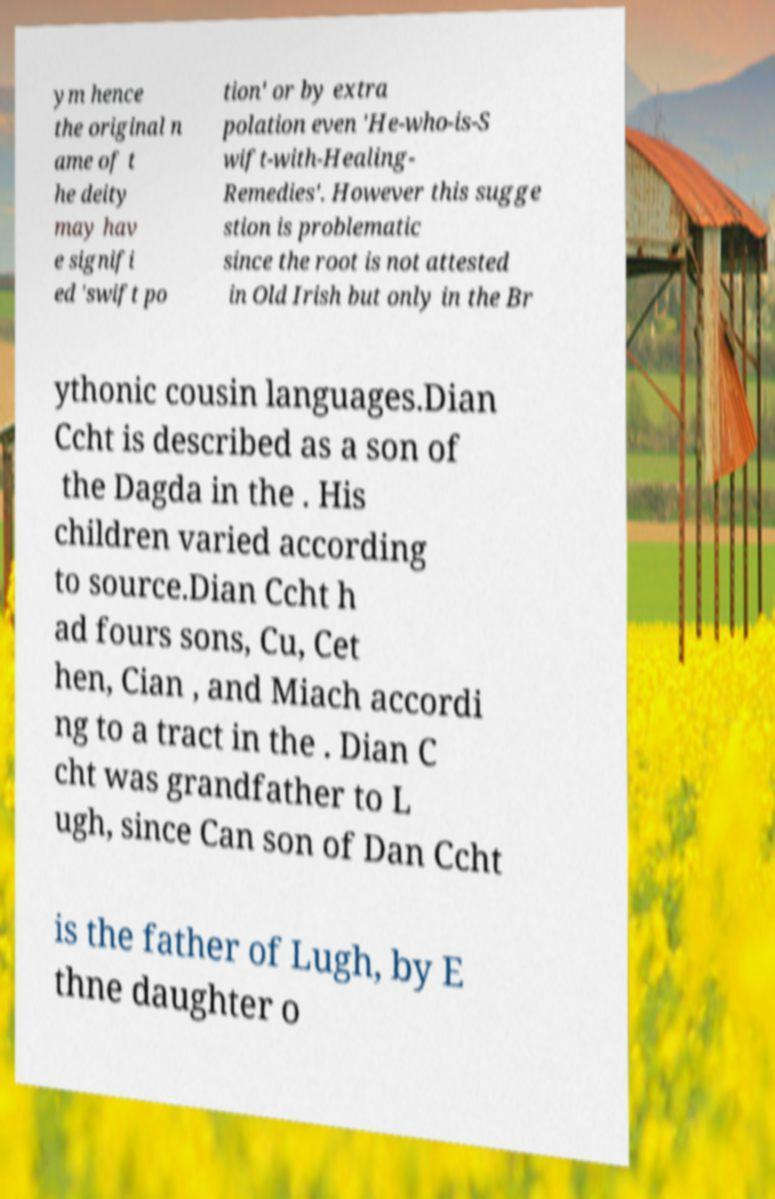Please identify and transcribe the text found in this image. ym hence the original n ame of t he deity may hav e signifi ed 'swift po tion' or by extra polation even 'He-who-is-S wift-with-Healing- Remedies'. However this sugge stion is problematic since the root is not attested in Old Irish but only in the Br ythonic cousin languages.Dian Ccht is described as a son of the Dagda in the . His children varied according to source.Dian Ccht h ad fours sons, Cu, Cet hen, Cian , and Miach accordi ng to a tract in the . Dian C cht was grandfather to L ugh, since Can son of Dan Ccht is the father of Lugh, by E thne daughter o 